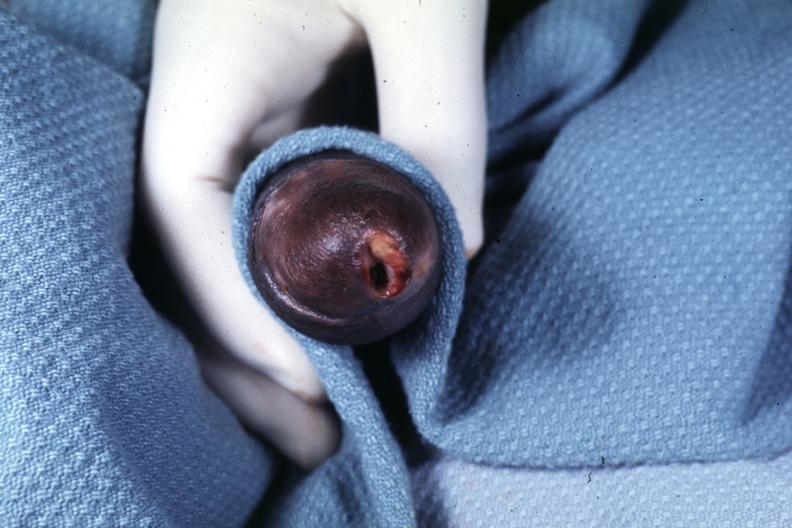s node metastases present?
Answer the question using a single word or phrase. No 